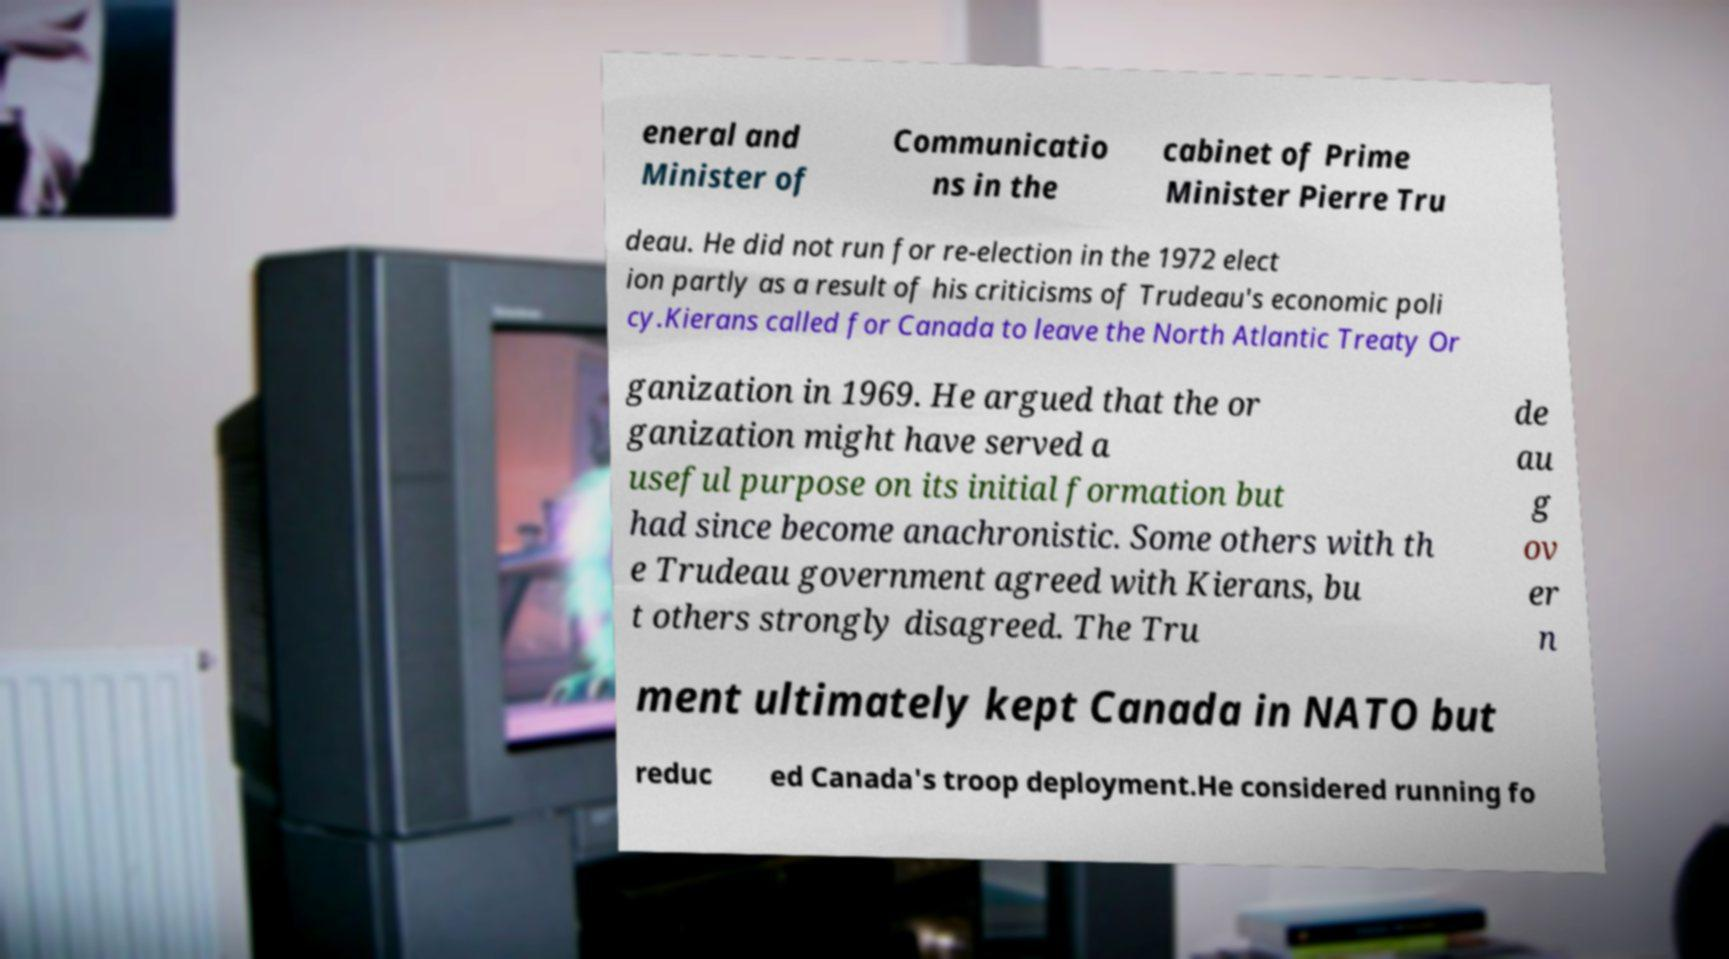Can you accurately transcribe the text from the provided image for me? eneral and Minister of Communicatio ns in the cabinet of Prime Minister Pierre Tru deau. He did not run for re-election in the 1972 elect ion partly as a result of his criticisms of Trudeau's economic poli cy.Kierans called for Canada to leave the North Atlantic Treaty Or ganization in 1969. He argued that the or ganization might have served a useful purpose on its initial formation but had since become anachronistic. Some others with th e Trudeau government agreed with Kierans, bu t others strongly disagreed. The Tru de au g ov er n ment ultimately kept Canada in NATO but reduc ed Canada's troop deployment.He considered running fo 